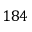Convert formula to latex. <formula><loc_0><loc_0><loc_500><loc_500>1 8 4</formula> 